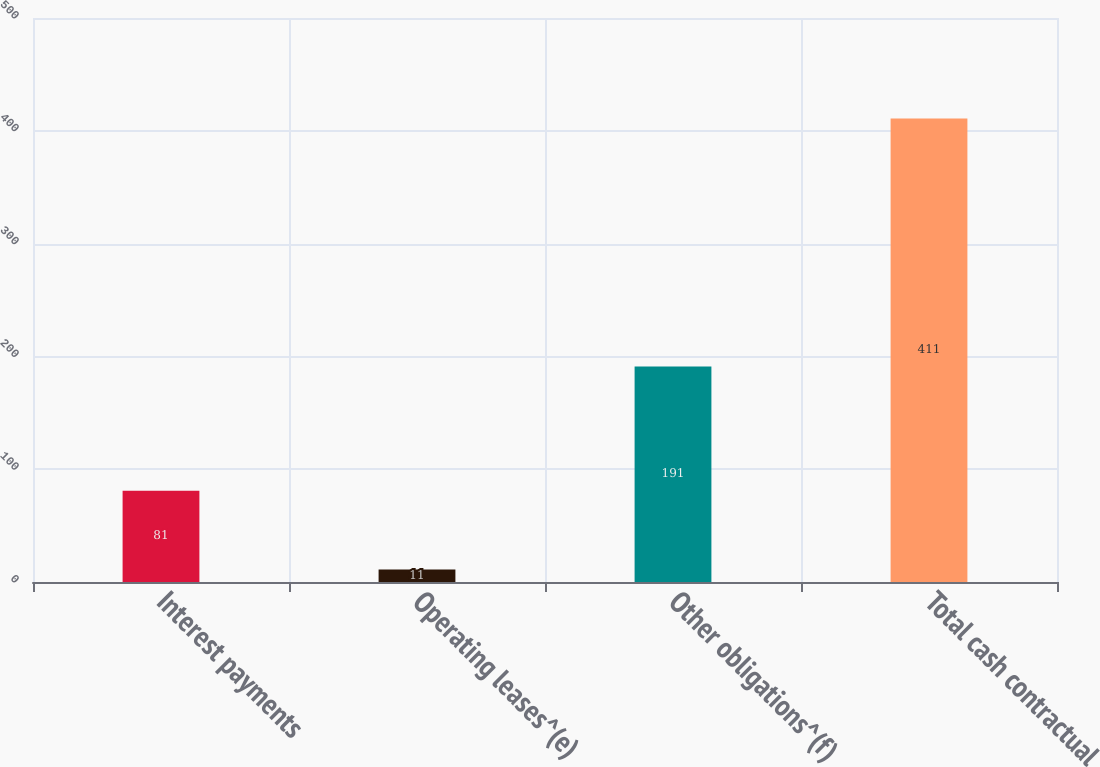<chart> <loc_0><loc_0><loc_500><loc_500><bar_chart><fcel>Interest payments<fcel>Operating leases^(e)<fcel>Other obligations^(f)<fcel>Total cash contractual<nl><fcel>81<fcel>11<fcel>191<fcel>411<nl></chart> 